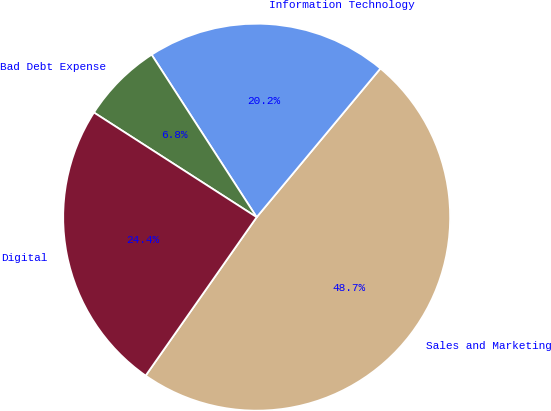<chart> <loc_0><loc_0><loc_500><loc_500><pie_chart><fcel>Sales and Marketing<fcel>Information Technology<fcel>Bad Debt Expense<fcel>Digital<nl><fcel>48.68%<fcel>20.18%<fcel>6.77%<fcel>24.37%<nl></chart> 